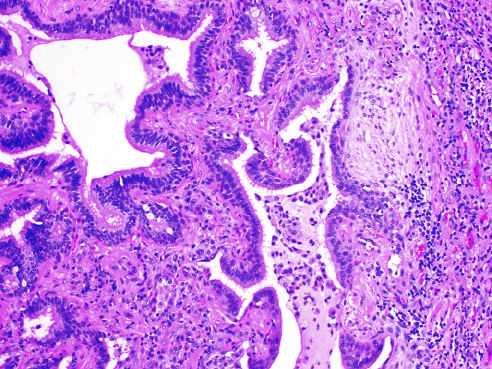what is present to the left?
Answer the question using a single word or phrase. Honey-combing 